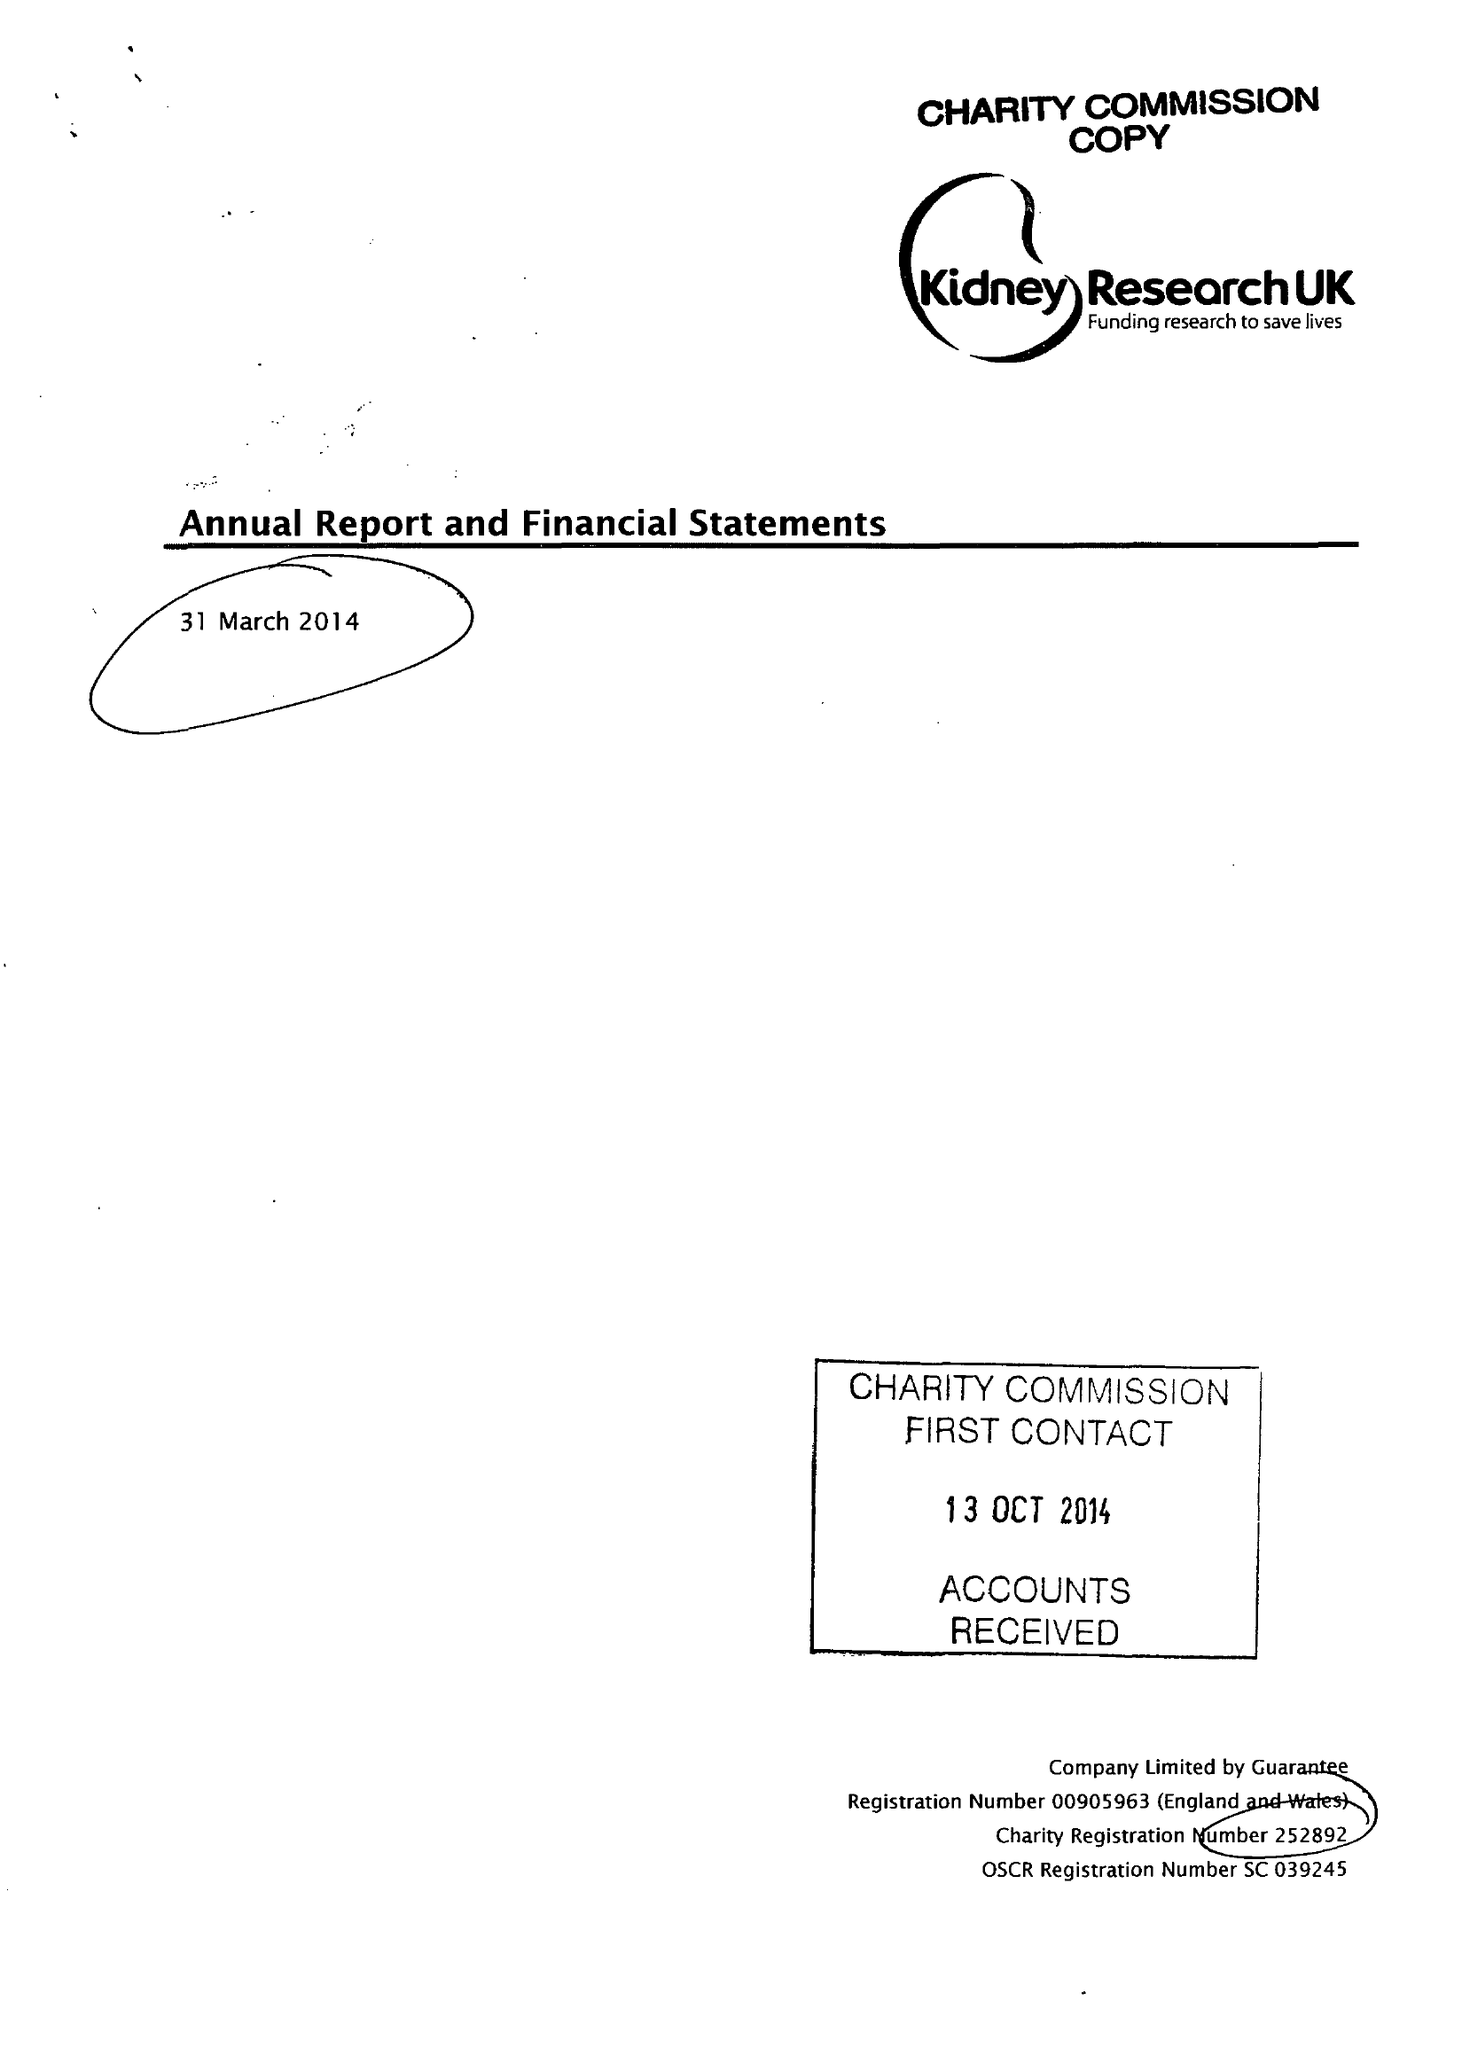What is the value for the charity_number?
Answer the question using a single word or phrase. 252892 